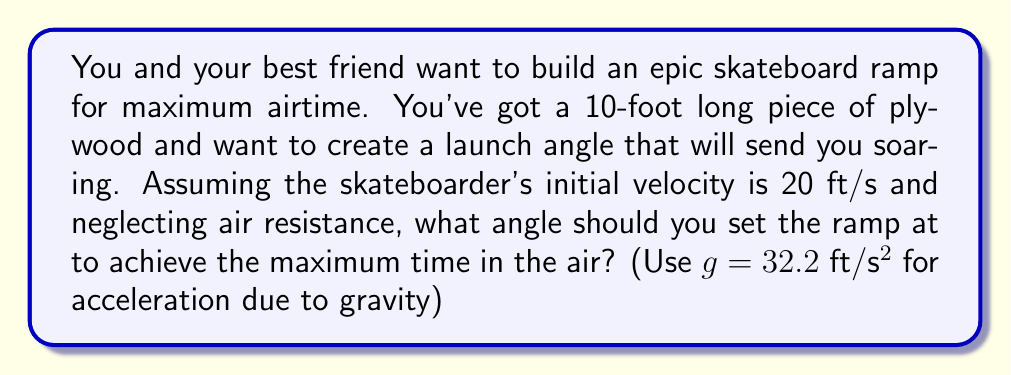What is the answer to this math problem? To solve this problem, we need to use principles of projectile motion. The time in the air is maximized when the vertical component of the initial velocity is maximized.

1) Let $\theta$ be the angle of the ramp. The initial velocity components are:
   $v_{0x} = v_0 \cos\theta$
   $v_{0y} = v_0 \sin\theta$

2) The time of flight for a projectile is given by:
   $t = \frac{2v_{0y}}{g} = \frac{2v_0 \sin\theta}{g}$

3) To maximize this, we need to maximize $\sin\theta$. The maximum value of $\sin\theta$ occurs when $\theta = 90°$, but this isn't practical for a skateboard ramp.

4) In reality, we need some horizontal velocity for the skateboarder to move forward. The optimal angle for projectile range is 45°, which balances horizontal and vertical motion.

5) Therefore, the optimal angle for maximizing air time while maintaining forward motion is 45°.

6) We can calculate the time in the air at this angle:
   $t = \frac{2v_0 \sin(45°)}{g} = \frac{2 \cdot 20 \cdot \frac{\sqrt{2}}{2}}{32.2} \approx 0.88$ seconds

[asy]
import geometry;

size(200);
draw((0,0)--(100,100),arrow=Arrow(TeXHead));
draw((0,0)--(141,0),arrow=Arrow(TeXHead));
draw((0,0)--(100,0),dashed);
draw((100,0)--(100,100),dashed);

label("45°",(20,0),SE);
label("v₀",(50,50),NW);
label("v₀y",(100,50),E);
label("v₀x",(50,0),S);

[/asy]
Answer: The optimal angle for the skateboard ramp to maximize air time while maintaining forward motion is 45°, resulting in approximately 0.88 seconds of air time. 